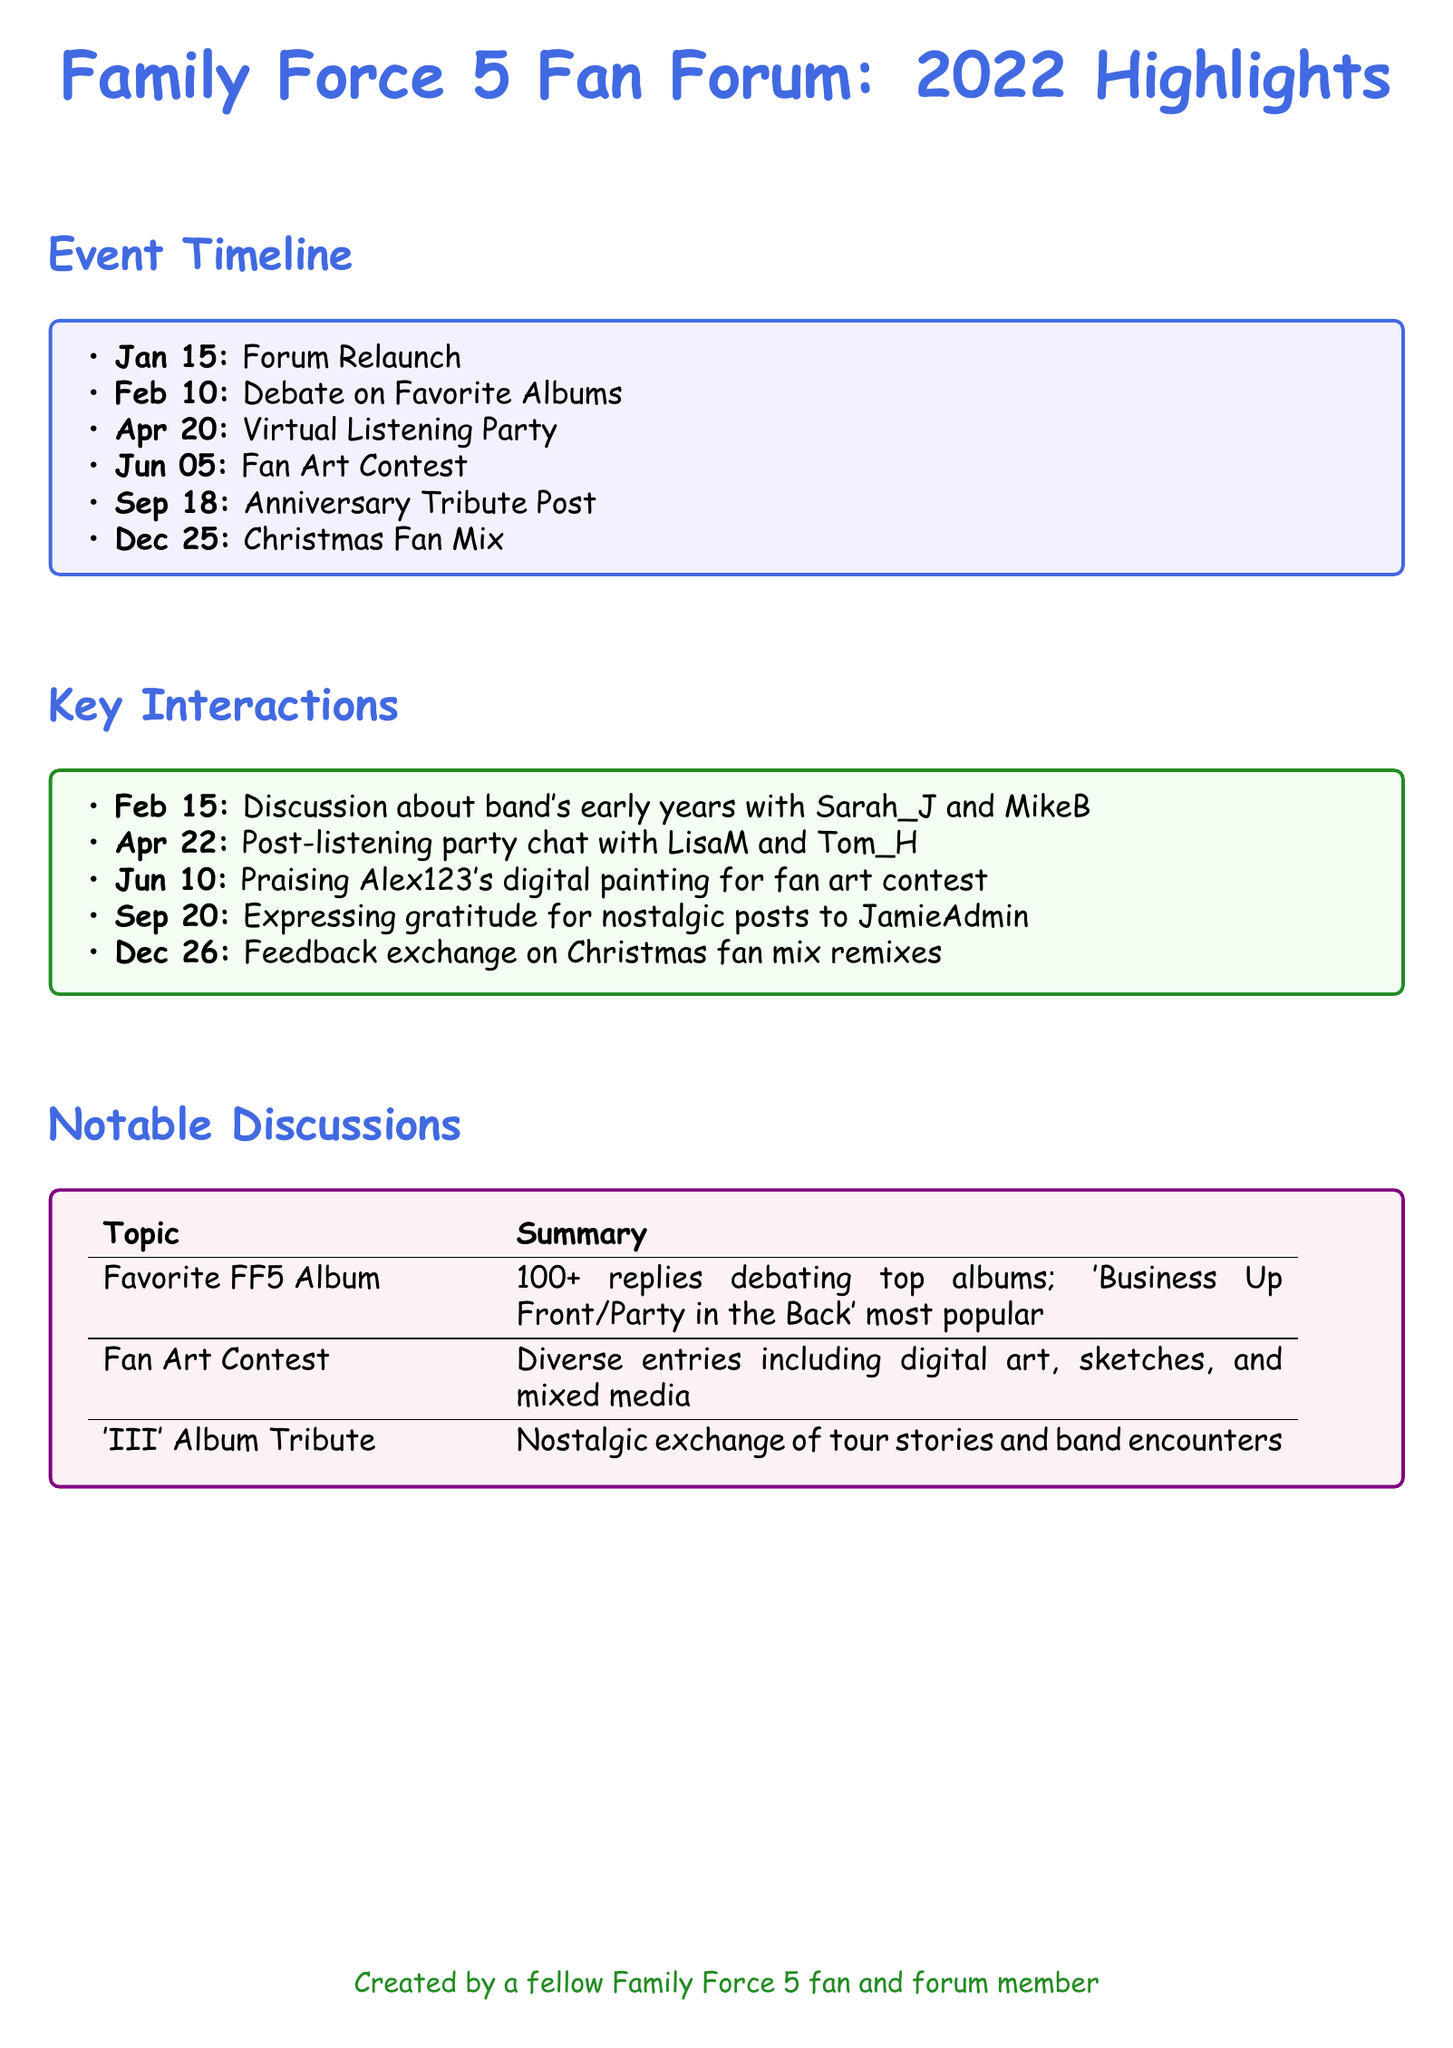What is the date of the forum relaunch? The forum relaunch event is specified as occurring on January 15.
Answer: January 15 How many replies were in the favorite album discussion? The document states that there were over 100 replies in the favorite album discussion.
Answer: 100+ Who was praised for their digital painting? The notable interaction mentions that Alex123's digital painting was praised during the fan art contest.
Answer: Alex123 What was the most popular album according to the favorite album debate? The document notes that 'Business Up Front/Party in the Back' was the most popular album in the discussion.
Answer: Business Up Front/Party in the Back What type of event happened on April 20? The document lists a Virtual Listening Party as the event that took place on April 20.
Answer: Virtual Listening Party Which fan showed gratitude for nostalgic posts? The document notes that JamieAdmin received gratitude for nostalgic posts on September 20.
Answer: JamieAdmin How many main events are listed in the timeline? The event timeline section contains a total of six main events.
Answer: 6 When did the Christmas fan mix take place? The Christmas fan mix event is specified to have occurred on December 25.
Answer: December 25 